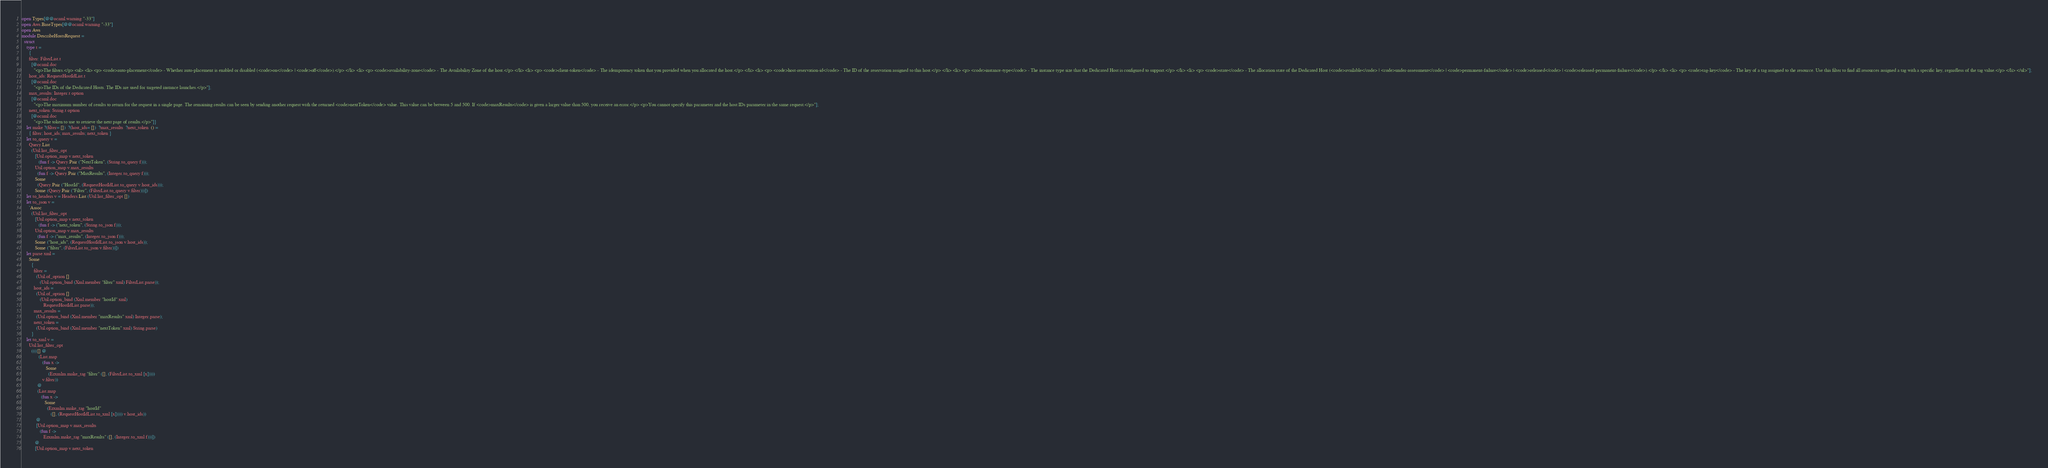<code> <loc_0><loc_0><loc_500><loc_500><_OCaml_>open Types[@@ocaml.warning "-33"]
open Aws.BaseTypes[@@ocaml.warning "-33"]
open Aws
module DescribeHostsRequest =
  struct
    type t =
      {
      filter: FilterList.t
        [@ocaml.doc
          "<p>The filters.</p> <ul> <li> <p> <code>auto-placement</code> - Whether auto-placement is enabled or disabled (<code>on</code> | <code>off</code>).</p> </li> <li> <p> <code>availability-zone</code> - The Availability Zone of the host.</p> </li> <li> <p> <code>client-token</code> - The idempotency token that you provided when you allocated the host.</p> </li> <li> <p> <code>host-reservation-id</code> - The ID of the reservation assigned to this host.</p> </li> <li> <p> <code>instance-type</code> - The instance type size that the Dedicated Host is configured to support.</p> </li> <li> <p> <code>state</code> - The allocation state of the Dedicated Host (<code>available</code> | <code>under-assessment</code> | <code>permanent-failure</code> | <code>released</code> | <code>released-permanent-failure</code>).</p> </li> <li> <p> <code>tag-key</code> - The key of a tag assigned to the resource. Use this filter to find all resources assigned a tag with a specific key, regardless of the tag value.</p> </li> </ul>"];
      host_ids: RequestHostIdList.t
        [@ocaml.doc
          "<p>The IDs of the Dedicated Hosts. The IDs are used for targeted instance launches.</p>"];
      max_results: Integer.t option
        [@ocaml.doc
          "<p>The maximum number of results to return for the request in a single page. The remaining results can be seen by sending another request with the returned <code>nextToken</code> value. This value can be between 5 and 500. If <code>maxResults</code> is given a larger value than 500, you receive an error.</p> <p>You cannot specify this parameter and the host IDs parameter in the same request.</p>"];
      next_token: String.t option
        [@ocaml.doc
          "<p>The token to use to retrieve the next page of results.</p>"]}
    let make ?(filter= [])  ?(host_ids= [])  ?max_results  ?next_token  () =
      { filter; host_ids; max_results; next_token }
    let to_query v =
      Query.List
        (Util.list_filter_opt
           [Util.option_map v.next_token
              (fun f -> Query.Pair ("NextToken", (String.to_query f)));
           Util.option_map v.max_results
             (fun f -> Query.Pair ("MaxResults", (Integer.to_query f)));
           Some
             (Query.Pair ("HostId", (RequestHostIdList.to_query v.host_ids)));
           Some (Query.Pair ("Filter", (FilterList.to_query v.filter)))])
    let to_headers v = Headers.List (Util.list_filter_opt [])
    let to_json v =
      `Assoc
        (Util.list_filter_opt
           [Util.option_map v.next_token
              (fun f -> ("next_token", (String.to_json f)));
           Util.option_map v.max_results
             (fun f -> ("max_results", (Integer.to_json f)));
           Some ("host_ids", (RequestHostIdList.to_json v.host_ids));
           Some ("filter", (FilterList.to_json v.filter))])
    let parse xml =
      Some
        {
          filter =
            (Util.of_option []
               (Util.option_bind (Xml.member "filter" xml) FilterList.parse));
          host_ids =
            (Util.of_option []
               (Util.option_bind (Xml.member "hostId" xml)
                  RequestHostIdList.parse));
          max_results =
            (Util.option_bind (Xml.member "maxResults" xml) Integer.parse);
          next_token =
            (Util.option_bind (Xml.member "nextToken" xml) String.parse)
        }
    let to_xml v =
      Util.list_filter_opt
        (((([] @
              (List.map
                 (fun x ->
                    Some
                      (Ezxmlm.make_tag "filter" ([], (FilterList.to_xml [x]))))
                 v.filter))
             @
             (List.map
                (fun x ->
                   Some
                     (Ezxmlm.make_tag "hostId"
                        ([], (RequestHostIdList.to_xml [x])))) v.host_ids))
            @
            [Util.option_map v.max_results
               (fun f ->
                  Ezxmlm.make_tag "maxResults" ([], (Integer.to_xml f)))])
           @
           [Util.option_map v.next_token</code> 